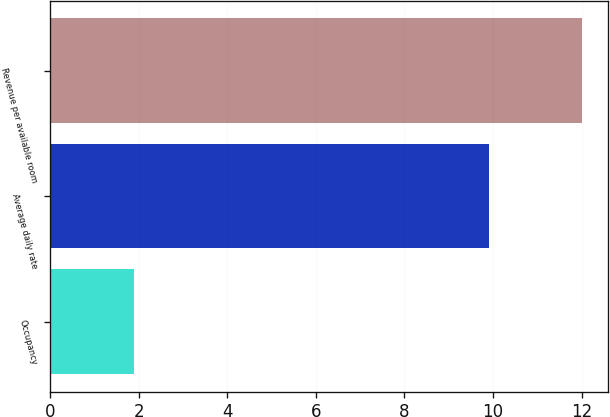<chart> <loc_0><loc_0><loc_500><loc_500><bar_chart><fcel>Occupancy<fcel>Average daily rate<fcel>Revenue per available room<nl><fcel>1.9<fcel>9.9<fcel>12<nl></chart> 